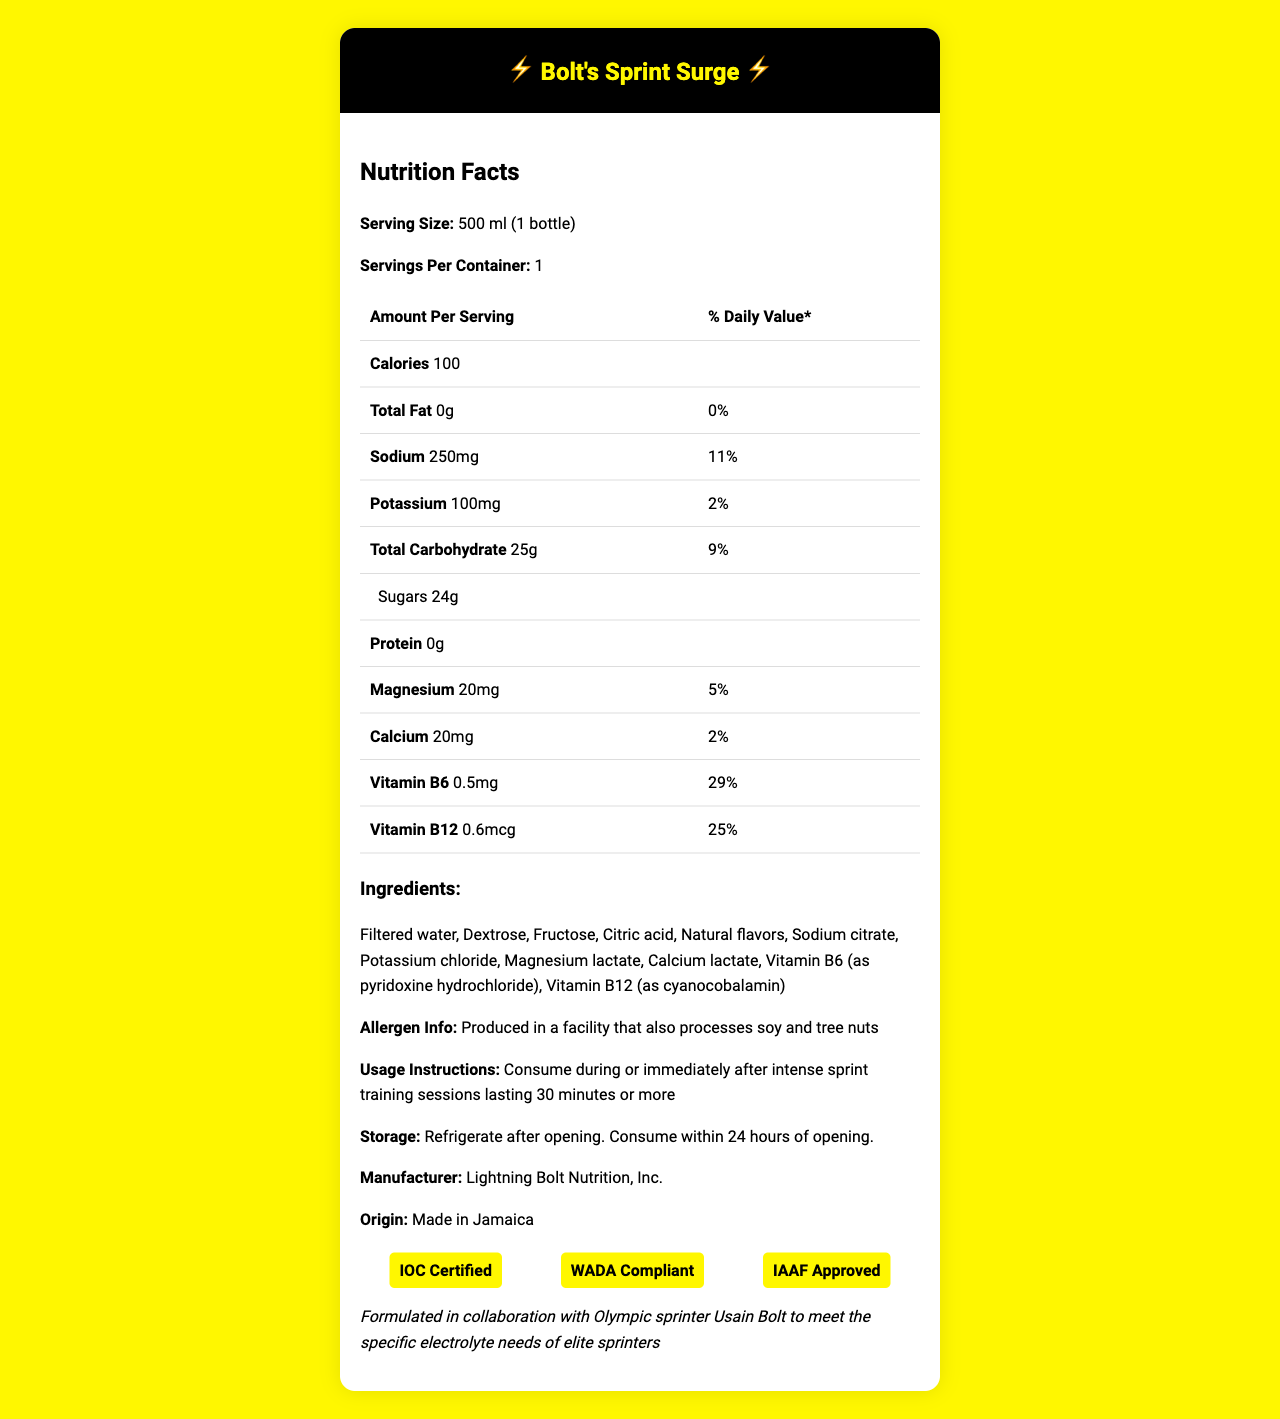which product has the highest percentage of Vitamin B6? A. Gatorade B. Powerade C. Bolt's Sprint Surge D. Pedialyte According to the document, Bolt's Sprint Surge contains 29% of the daily value of Vitamin B6.
Answer: C. Bolt's Sprint Surge how many calories are in Bolt's Sprint Surge? The document states that there are 100 calories per serving, and each serving is 500 ml or one bottle.
Answer: 100 calories what is the sodium content per bottle? The document lists the sodium content as 250 mg per 500 ml serving.
Answer: 250 mg is the product allergen-free? The document notes that the product is produced in a facility that also processes soy and tree nuts.
Answer: No where was Bolt's Sprint Surge manufactured? The document specifies that the product was made in Jamaica.
Answer: Jamaica what is the daily value percentage of calcium in this sports drink? The document indicates that the calcium content provides 2% of the daily value per serving.
Answer: 2% what ingredient follows "Citric acid" in the list of ingredients? In the ingredients list, "Natural flavors" follows "Citric acid".
Answer: Natural flavors how should the drink be stored after opening? The storage instructions specify that the drink should be refrigerated after opening and consumed within 24 hours.
Answer: Refrigerate after opening. Consume within 24 hours of opening. which vitamin has a higher daily value percentage, Vitamin B6 or Vitamin B12? Vitamin B6 has a daily value percentage of 29%, while Vitamin B12 has 25%.
Answer: Vitamin B6 what certifications does Bolt's Sprint Surge hold? A. IOC Certified B. WADA Compliant C. IAAF Approved D. All of the above The document lists IOC Certified, WADA Compliant, and IAAF Approved as the certifications for Bolt's Sprint Surge.
Answer: D. All of the above what is the main purpose of consuming Bolt's Sprint Surge? A. Weight loss B. Replenishing electrolytes C. Muscle building D. Relaxation The product is formulated to replenish electrolytes lost during intense sprint training, as stated in the document.
Answer: B. Replenishing electrolytes can this product be consumed during a light, regular jogging session of 15 minutes? The usage instructions specify that the product should be consumed during or immediately after intense sprint training sessions lasting 30 minutes or more.
Answer: No describe the main features of Bolt's Sprint Surge. The document provides details such as nutritional content, ingredients, allergen information, usage instructions, certifications, and additional info about the purpose and formulation of the sports drink.
Answer: Bolt's Sprint Surge is a sports drink formulated to replenish electrolytes lost during intense sprint training. It contains 100 calories, 0g fat, 250mg sodium, 100mg potassium, 24g sugars, and essential vitamins like B6 and B12. It is made with filtered water, dextrose, fructose, and other ingredients. The product is IOC Certified, WADA Compliant, and IAAF Approved. Produced in a facility that processes soy and tree nuts, it should be refrigerated after opening and consumed within 24 hours. how many grams of protein are in Bolt's Sprint Surge? The document states that the product has 0 grams of protein.
Answer: 0g what is the origin of the natural flavors used in Bolt's Sprint Surge? The document lists "Natural flavors" as an ingredient but does not specify their origin.
Answer: Not enough information how many servings are in one container? The document clearly states that each container holds one serving of 500 ml.
Answer: 1 